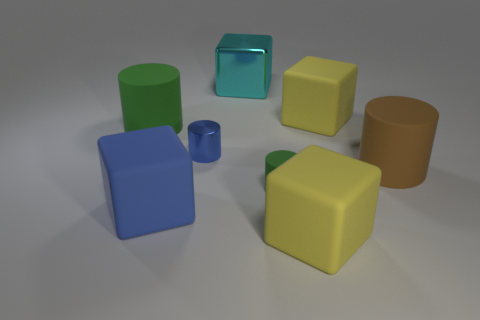Subtract all tiny metallic cylinders. How many cylinders are left? 3 Add 1 yellow metal objects. How many objects exist? 9 Subtract 3 cylinders. How many cylinders are left? 1 Subtract all green cylinders. How many cylinders are left? 2 Subtract all cyan cylinders. Subtract all gray spheres. How many cylinders are left? 4 Subtract all gray cubes. How many brown cylinders are left? 1 Subtract all big cyan objects. Subtract all brown things. How many objects are left? 6 Add 3 yellow matte things. How many yellow matte things are left? 5 Add 5 small purple rubber things. How many small purple rubber things exist? 5 Subtract 0 purple spheres. How many objects are left? 8 